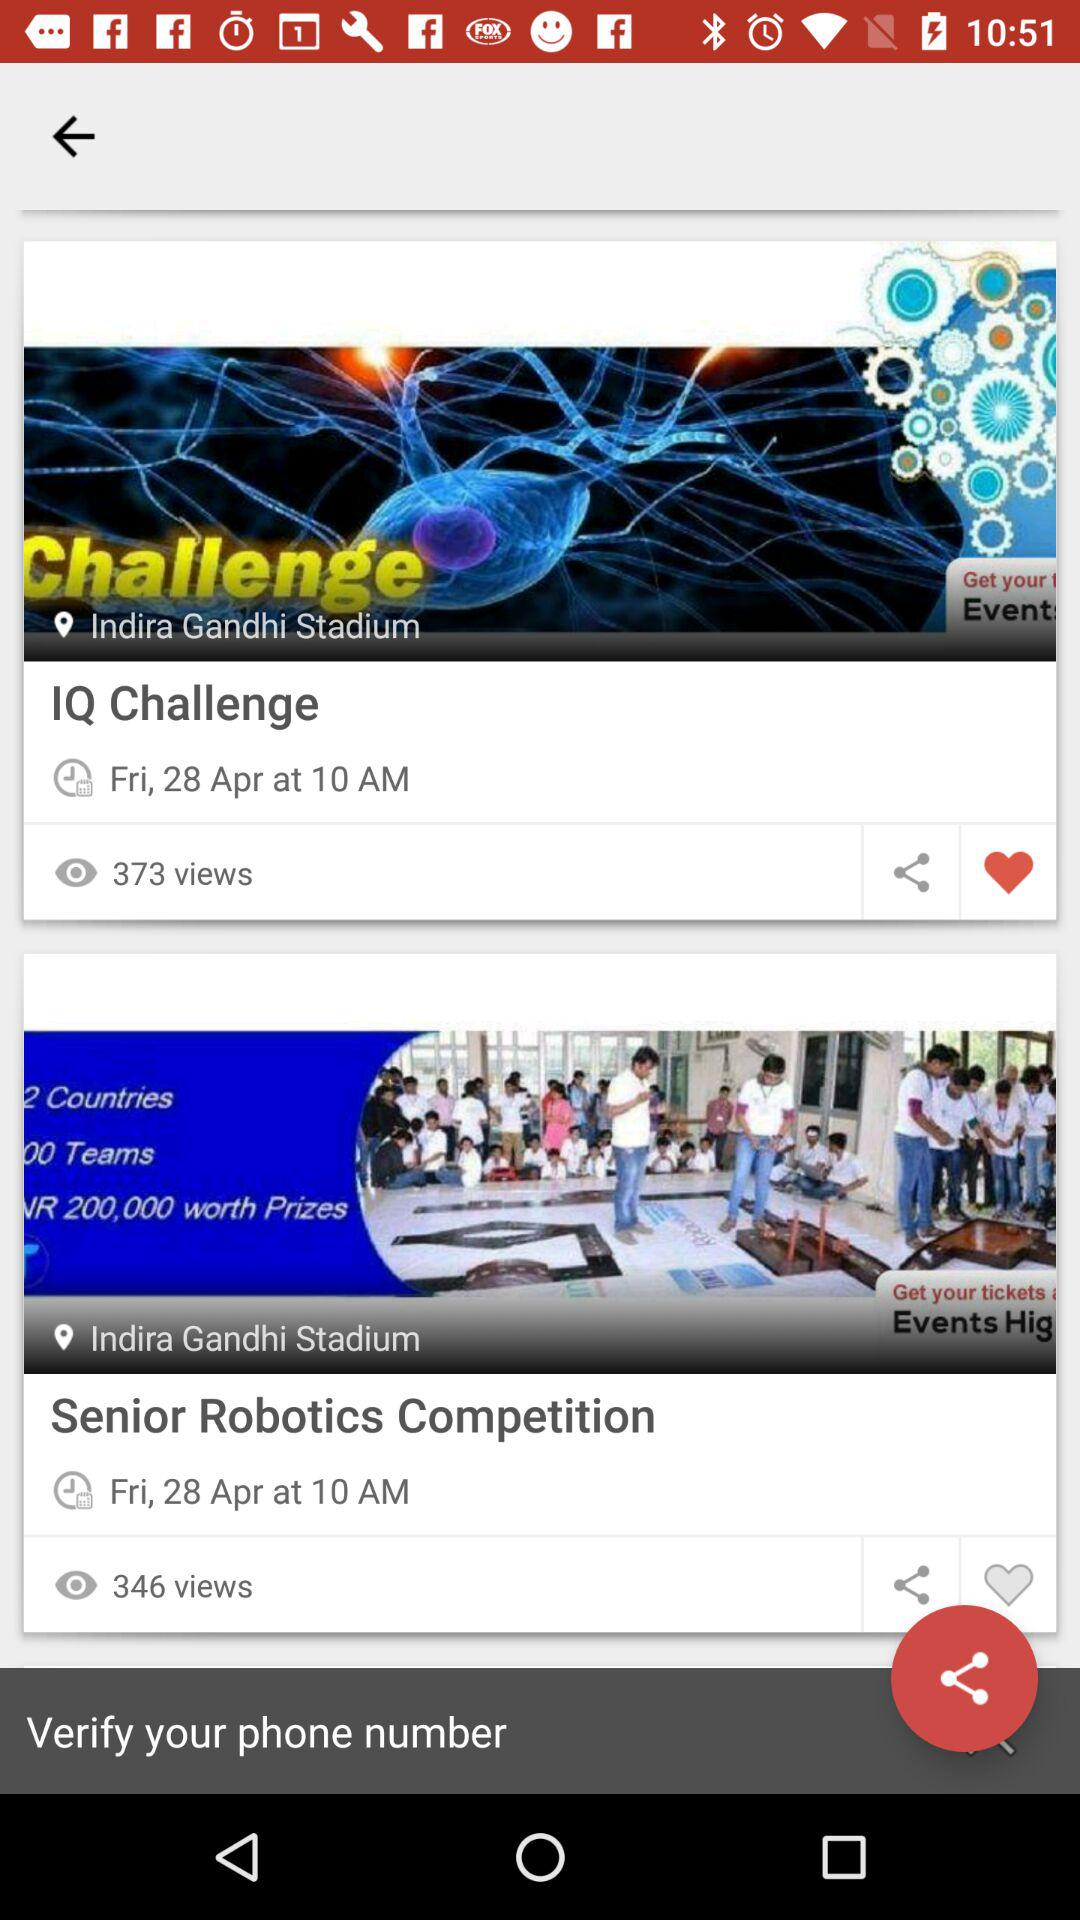What is the date of the "IQ Challenge"? The date of the "IQ Challenge" is Friday, April 28. 